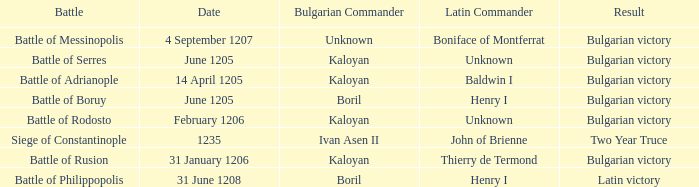What is the Result of the battle with Latin Commander Boniface of Montferrat? Bulgarian victory. I'm looking to parse the entire table for insights. Could you assist me with that? {'header': ['Battle', 'Date', 'Bulgarian Commander', 'Latin Commander', 'Result'], 'rows': [['Battle of Messinopolis', '4 September 1207', 'Unknown', 'Boniface of Montferrat', 'Bulgarian victory'], ['Battle of Serres', 'June 1205', 'Kaloyan', 'Unknown', 'Bulgarian victory'], ['Battle of Adrianople', '14 April 1205', 'Kaloyan', 'Baldwin I', 'Bulgarian victory'], ['Battle of Boruy', 'June 1205', 'Boril', 'Henry I', 'Bulgarian victory'], ['Battle of Rodosto', 'February 1206', 'Kaloyan', 'Unknown', 'Bulgarian victory'], ['Siege of Constantinople', '1235', 'Ivan Asen II', 'John of Brienne', 'Two Year Truce'], ['Battle of Rusion', '31 January 1206', 'Kaloyan', 'Thierry de Termond', 'Bulgarian victory'], ['Battle of Philippopolis', '31 June 1208', 'Boril', 'Henry I', 'Latin victory']]} 